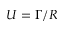Convert formula to latex. <formula><loc_0><loc_0><loc_500><loc_500>U = \Gamma / R</formula> 